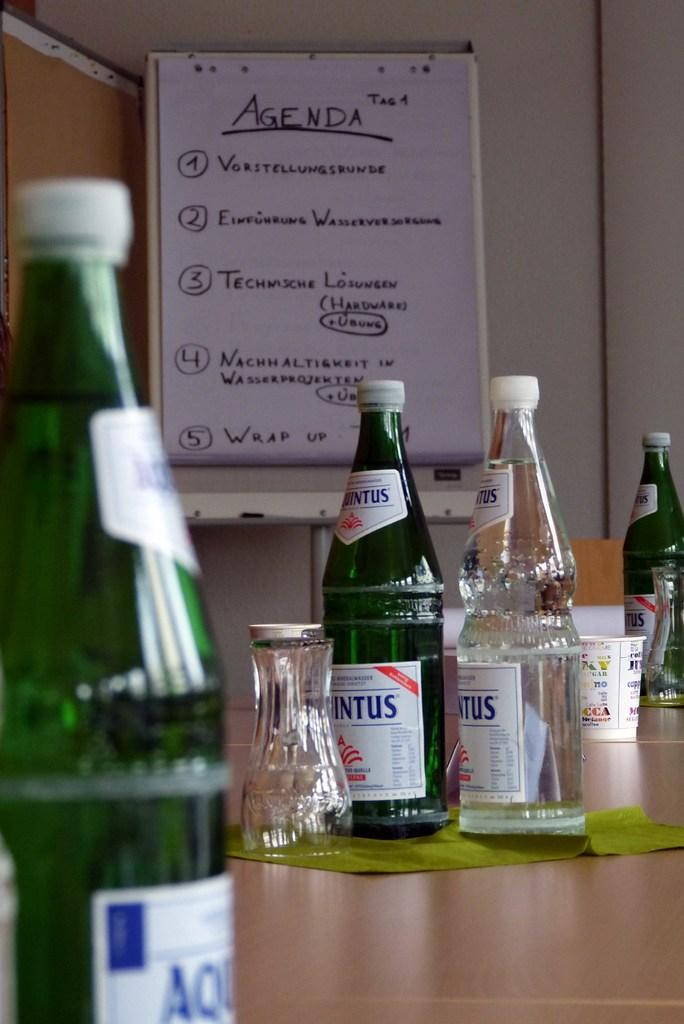What objects are on the table in the image? There are bottles and glasses on the table in the image. What can be said about the color of the bottles on the left side? The bottles on the left side are green in color. What is located behind the bottles on the table? There is a whiteboard behind the bottles. What is written on the whiteboard? The agenda is written on the whiteboard. What type of curve can be seen on the board in the image? There is no board present in the image, only a whiteboard. Additionally, there are no curves visible on the whiteboard. 